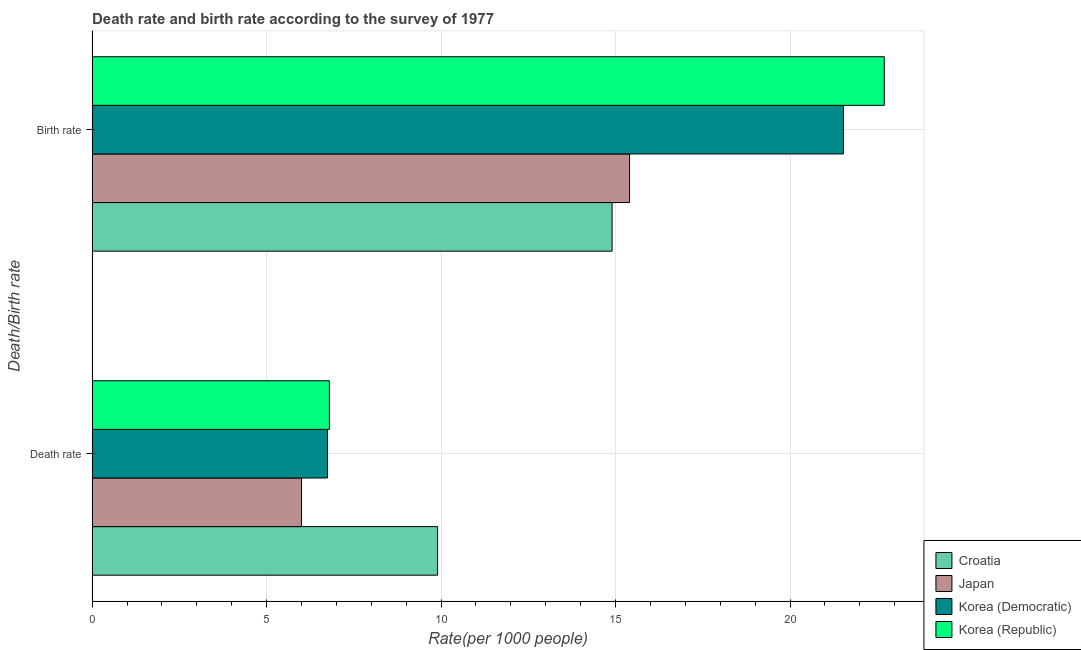How many groups of bars are there?
Your response must be concise. 2. Are the number of bars per tick equal to the number of legend labels?
Ensure brevity in your answer.  Yes. What is the label of the 1st group of bars from the top?
Make the answer very short. Birth rate. What is the death rate in Korea (Republic)?
Your answer should be very brief. 6.8. Across all countries, what is the maximum birth rate?
Keep it short and to the point. 22.7. Across all countries, what is the minimum death rate?
Make the answer very short. 6. In which country was the birth rate maximum?
Your answer should be very brief. Korea (Republic). What is the total death rate in the graph?
Make the answer very short. 29.44. What is the difference between the death rate in Korea (Republic) and that in Japan?
Provide a short and direct response. 0.8. What is the difference between the death rate in Croatia and the birth rate in Korea (Democratic)?
Offer a very short reply. -11.63. What is the average birth rate per country?
Give a very brief answer. 18.63. In how many countries, is the death rate greater than 20 ?
Your answer should be very brief. 0. What is the ratio of the birth rate in Korea (Democratic) to that in Croatia?
Your answer should be compact. 1.44. Is the birth rate in Croatia less than that in Korea (Democratic)?
Your response must be concise. Yes. In how many countries, is the death rate greater than the average death rate taken over all countries?
Provide a short and direct response. 1. What does the 4th bar from the top in Birth rate represents?
Your answer should be compact. Croatia. How many bars are there?
Offer a terse response. 8. Are all the bars in the graph horizontal?
Keep it short and to the point. Yes. How many countries are there in the graph?
Keep it short and to the point. 4. Does the graph contain any zero values?
Give a very brief answer. No. How many legend labels are there?
Your answer should be compact. 4. How are the legend labels stacked?
Make the answer very short. Vertical. What is the title of the graph?
Your answer should be compact. Death rate and birth rate according to the survey of 1977. What is the label or title of the X-axis?
Your answer should be very brief. Rate(per 1000 people). What is the label or title of the Y-axis?
Make the answer very short. Death/Birth rate. What is the Rate(per 1000 people) in Croatia in Death rate?
Make the answer very short. 9.9. What is the Rate(per 1000 people) of Japan in Death rate?
Offer a terse response. 6. What is the Rate(per 1000 people) of Korea (Democratic) in Death rate?
Ensure brevity in your answer.  6.74. What is the Rate(per 1000 people) in Korea (Republic) in Death rate?
Give a very brief answer. 6.8. What is the Rate(per 1000 people) of Croatia in Birth rate?
Make the answer very short. 14.9. What is the Rate(per 1000 people) of Korea (Democratic) in Birth rate?
Offer a terse response. 21.53. What is the Rate(per 1000 people) in Korea (Republic) in Birth rate?
Your response must be concise. 22.7. Across all Death/Birth rate, what is the maximum Rate(per 1000 people) of Japan?
Your response must be concise. 15.4. Across all Death/Birth rate, what is the maximum Rate(per 1000 people) in Korea (Democratic)?
Your response must be concise. 21.53. Across all Death/Birth rate, what is the maximum Rate(per 1000 people) of Korea (Republic)?
Give a very brief answer. 22.7. Across all Death/Birth rate, what is the minimum Rate(per 1000 people) in Croatia?
Keep it short and to the point. 9.9. Across all Death/Birth rate, what is the minimum Rate(per 1000 people) of Japan?
Your response must be concise. 6. Across all Death/Birth rate, what is the minimum Rate(per 1000 people) in Korea (Democratic)?
Ensure brevity in your answer.  6.74. Across all Death/Birth rate, what is the minimum Rate(per 1000 people) of Korea (Republic)?
Your answer should be very brief. 6.8. What is the total Rate(per 1000 people) of Croatia in the graph?
Ensure brevity in your answer.  24.8. What is the total Rate(per 1000 people) in Japan in the graph?
Your response must be concise. 21.4. What is the total Rate(per 1000 people) in Korea (Democratic) in the graph?
Offer a very short reply. 28.27. What is the total Rate(per 1000 people) in Korea (Republic) in the graph?
Your answer should be very brief. 29.5. What is the difference between the Rate(per 1000 people) of Croatia in Death rate and that in Birth rate?
Offer a terse response. -5. What is the difference between the Rate(per 1000 people) in Japan in Death rate and that in Birth rate?
Offer a terse response. -9.4. What is the difference between the Rate(per 1000 people) of Korea (Democratic) in Death rate and that in Birth rate?
Give a very brief answer. -14.79. What is the difference between the Rate(per 1000 people) of Korea (Republic) in Death rate and that in Birth rate?
Your response must be concise. -15.9. What is the difference between the Rate(per 1000 people) in Croatia in Death rate and the Rate(per 1000 people) in Korea (Democratic) in Birth rate?
Provide a short and direct response. -11.63. What is the difference between the Rate(per 1000 people) of Japan in Death rate and the Rate(per 1000 people) of Korea (Democratic) in Birth rate?
Your answer should be very brief. -15.53. What is the difference between the Rate(per 1000 people) of Japan in Death rate and the Rate(per 1000 people) of Korea (Republic) in Birth rate?
Keep it short and to the point. -16.7. What is the difference between the Rate(per 1000 people) in Korea (Democratic) in Death rate and the Rate(per 1000 people) in Korea (Republic) in Birth rate?
Provide a succinct answer. -15.96. What is the average Rate(per 1000 people) of Croatia per Death/Birth rate?
Offer a very short reply. 12.4. What is the average Rate(per 1000 people) of Japan per Death/Birth rate?
Offer a terse response. 10.7. What is the average Rate(per 1000 people) of Korea (Democratic) per Death/Birth rate?
Your answer should be very brief. 14.14. What is the average Rate(per 1000 people) in Korea (Republic) per Death/Birth rate?
Your response must be concise. 14.75. What is the difference between the Rate(per 1000 people) of Croatia and Rate(per 1000 people) of Japan in Death rate?
Offer a very short reply. 3.9. What is the difference between the Rate(per 1000 people) of Croatia and Rate(per 1000 people) of Korea (Democratic) in Death rate?
Offer a very short reply. 3.16. What is the difference between the Rate(per 1000 people) in Croatia and Rate(per 1000 people) in Korea (Republic) in Death rate?
Provide a short and direct response. 3.1. What is the difference between the Rate(per 1000 people) of Japan and Rate(per 1000 people) of Korea (Democratic) in Death rate?
Provide a succinct answer. -0.74. What is the difference between the Rate(per 1000 people) in Japan and Rate(per 1000 people) in Korea (Republic) in Death rate?
Offer a terse response. -0.8. What is the difference between the Rate(per 1000 people) of Korea (Democratic) and Rate(per 1000 people) of Korea (Republic) in Death rate?
Keep it short and to the point. -0.06. What is the difference between the Rate(per 1000 people) in Croatia and Rate(per 1000 people) in Korea (Democratic) in Birth rate?
Provide a succinct answer. -6.63. What is the difference between the Rate(per 1000 people) in Japan and Rate(per 1000 people) in Korea (Democratic) in Birth rate?
Give a very brief answer. -6.13. What is the difference between the Rate(per 1000 people) in Korea (Democratic) and Rate(per 1000 people) in Korea (Republic) in Birth rate?
Your answer should be compact. -1.17. What is the ratio of the Rate(per 1000 people) in Croatia in Death rate to that in Birth rate?
Provide a short and direct response. 0.66. What is the ratio of the Rate(per 1000 people) of Japan in Death rate to that in Birth rate?
Provide a short and direct response. 0.39. What is the ratio of the Rate(per 1000 people) of Korea (Democratic) in Death rate to that in Birth rate?
Your response must be concise. 0.31. What is the ratio of the Rate(per 1000 people) in Korea (Republic) in Death rate to that in Birth rate?
Give a very brief answer. 0.3. What is the difference between the highest and the second highest Rate(per 1000 people) in Croatia?
Ensure brevity in your answer.  5. What is the difference between the highest and the second highest Rate(per 1000 people) of Japan?
Offer a terse response. 9.4. What is the difference between the highest and the second highest Rate(per 1000 people) of Korea (Democratic)?
Provide a succinct answer. 14.79. What is the difference between the highest and the lowest Rate(per 1000 people) of Japan?
Offer a terse response. 9.4. What is the difference between the highest and the lowest Rate(per 1000 people) in Korea (Democratic)?
Ensure brevity in your answer.  14.79. What is the difference between the highest and the lowest Rate(per 1000 people) of Korea (Republic)?
Give a very brief answer. 15.9. 